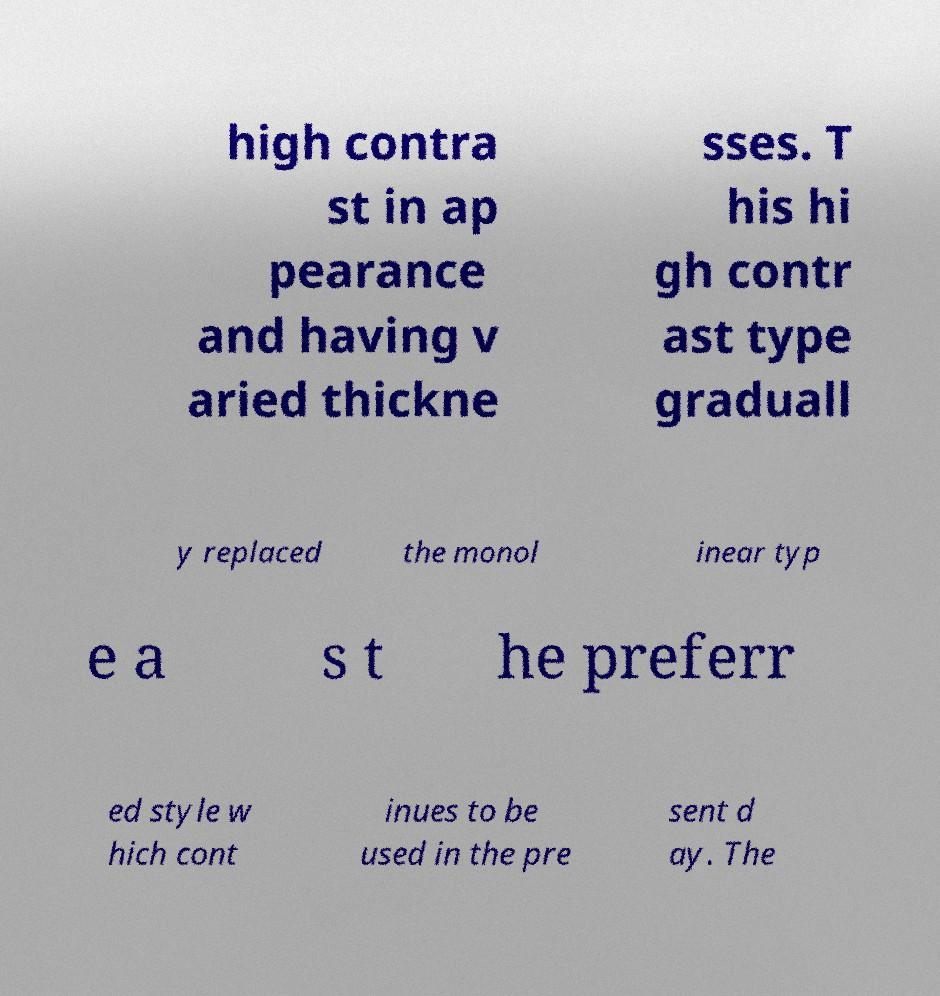Could you extract and type out the text from this image? high contra st in ap pearance and having v aried thickne sses. T his hi gh contr ast type graduall y replaced the monol inear typ e a s t he preferr ed style w hich cont inues to be used in the pre sent d ay. The 